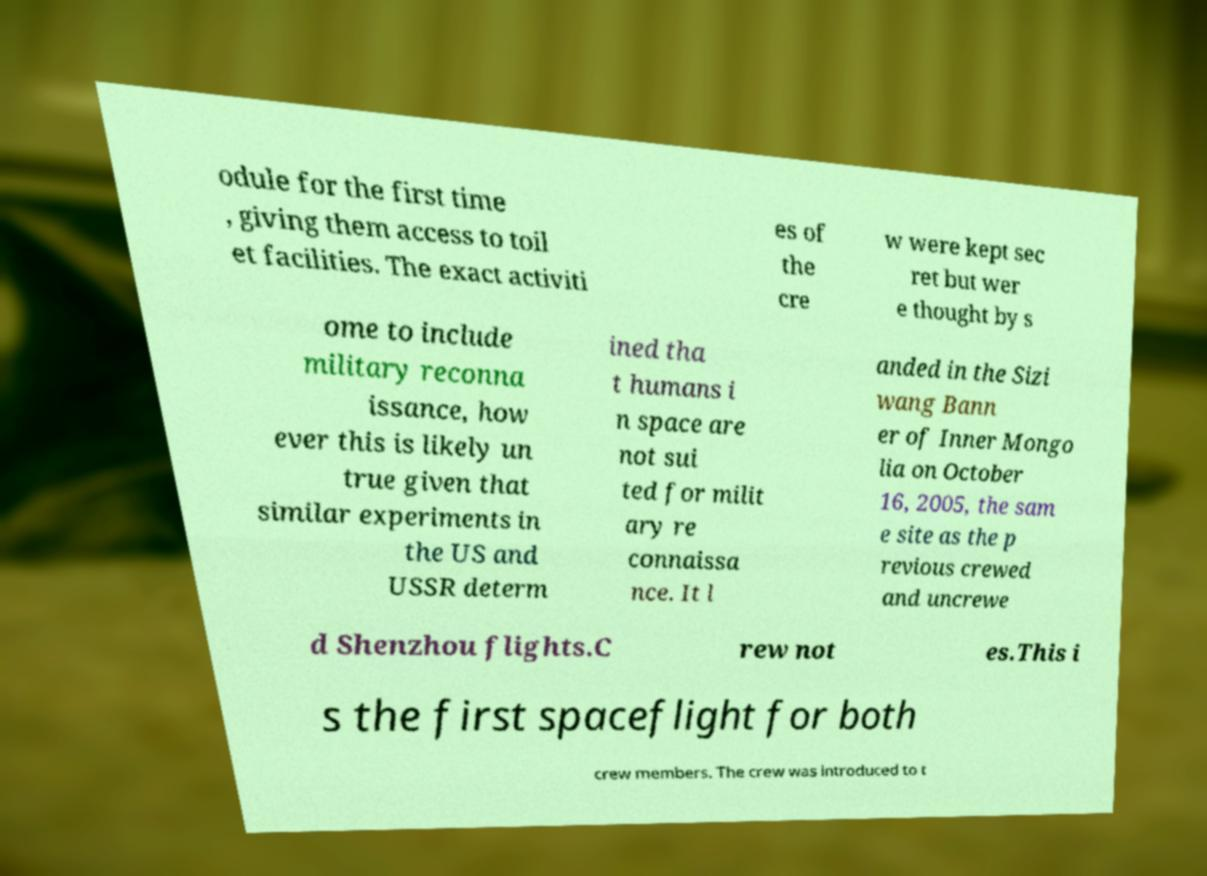Please read and relay the text visible in this image. What does it say? odule for the first time , giving them access to toil et facilities. The exact activiti es of the cre w were kept sec ret but wer e thought by s ome to include military reconna issance, how ever this is likely un true given that similar experiments in the US and USSR determ ined tha t humans i n space are not sui ted for milit ary re connaissa nce. It l anded in the Sizi wang Bann er of Inner Mongo lia on October 16, 2005, the sam e site as the p revious crewed and uncrewe d Shenzhou flights.C rew not es.This i s the first spaceflight for both crew members. The crew was introduced to t 